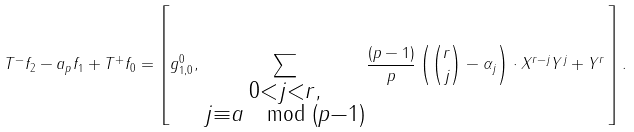Convert formula to latex. <formula><loc_0><loc_0><loc_500><loc_500>T ^ { - } f _ { 2 } - a _ { p } f _ { 1 } + T ^ { + } f _ { 0 } = \left [ g _ { 1 , 0 } ^ { 0 } , \, \underset { \substack { 0 < j < r , \\ j \equiv a \mod ( p - 1 ) } } \sum \frac { ( p - 1 ) } { p } \left ( \binom { r } { j } - \alpha _ { j } \right ) \cdot X ^ { r - j } Y ^ { j } + Y ^ { r } \, \right ] .</formula> 